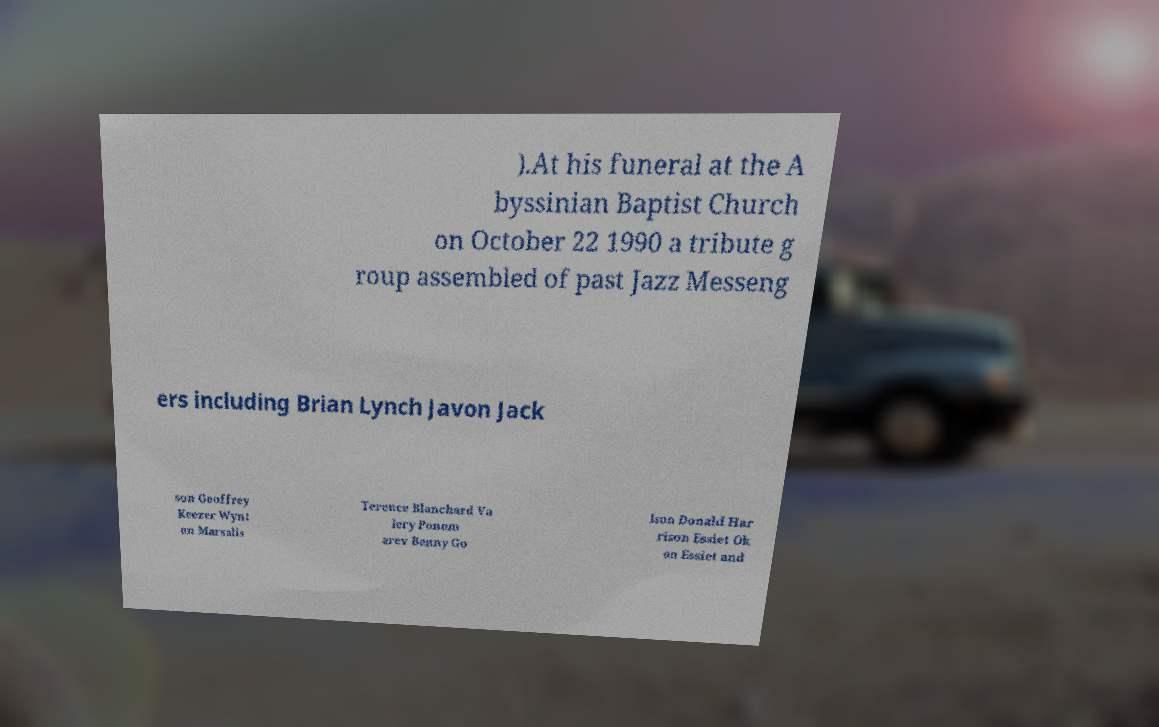Can you read and provide the text displayed in the image?This photo seems to have some interesting text. Can you extract and type it out for me? ).At his funeral at the A byssinian Baptist Church on October 22 1990 a tribute g roup assembled of past Jazz Messeng ers including Brian Lynch Javon Jack son Geoffrey Keezer Wynt on Marsalis Terence Blanchard Va lery Ponom arev Benny Go lson Donald Har rison Essiet Ok on Essiet and 